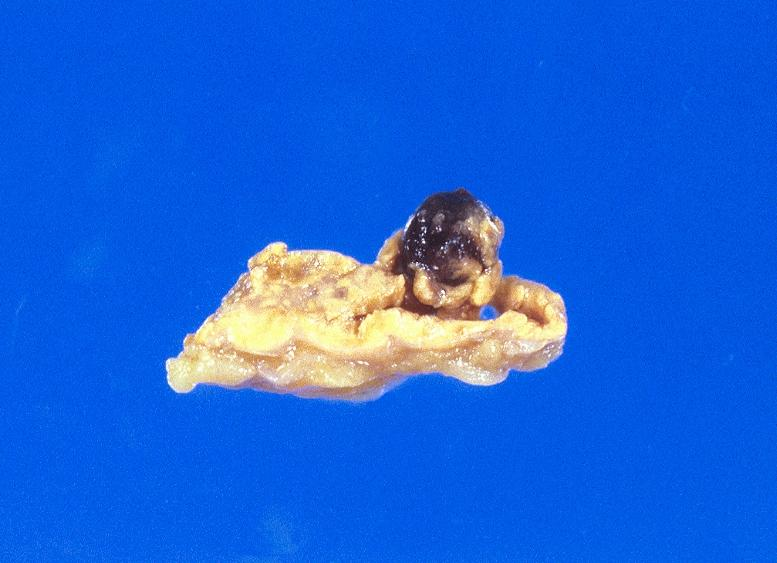s soft tissue present?
Answer the question using a single word or phrase. Yes 